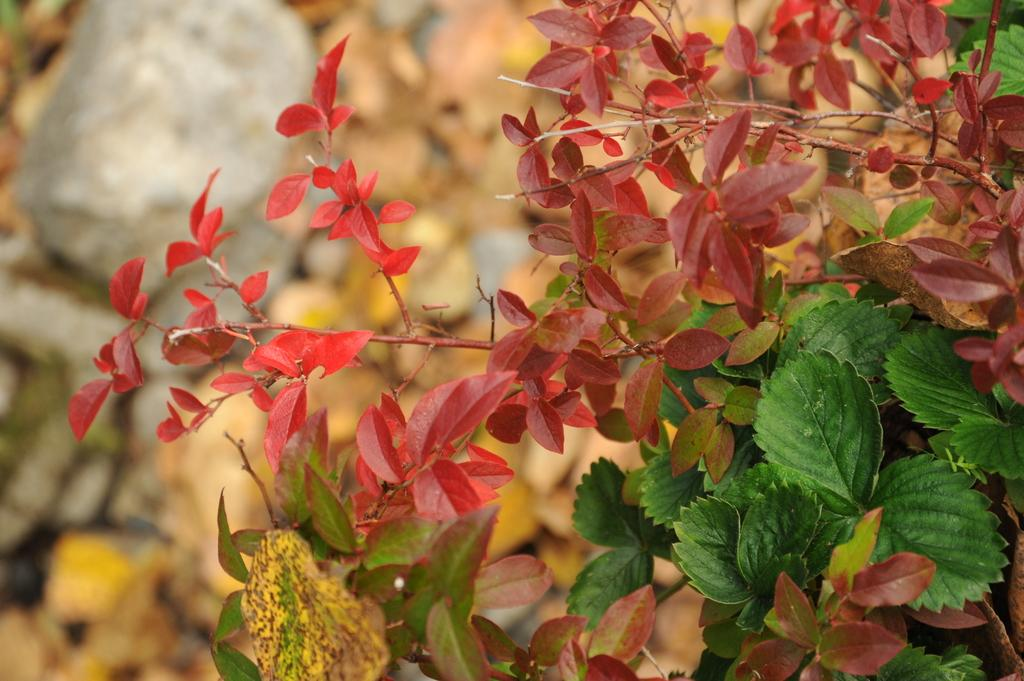What type of living organisms can be seen in the image? Plants can be seen in the image. How much of the land is covered by the plants? The plants cover the land in the image. Can you describe any other objects or features in the background of the image? There is a rock in the left side background of the image. Who is the owner of the pipe in the image? There is no pipe present in the image. How many eggs are visible in the image? There are no eggs present in the image. 